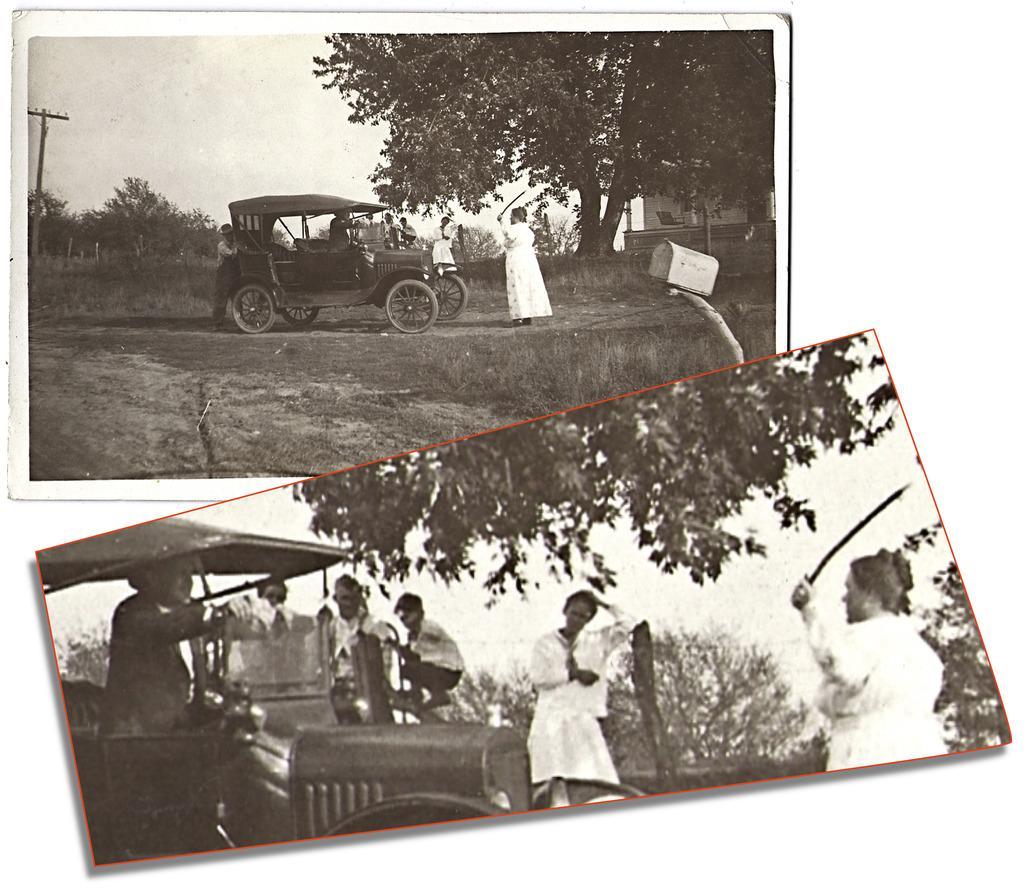Please provide a concise description of this image. In this image we can see a collage pictures, in both the pictures we can see a few people, vehicles, trees, in the top picture we can see an electric pole, a mailbox and a house, also we can see the sky. 